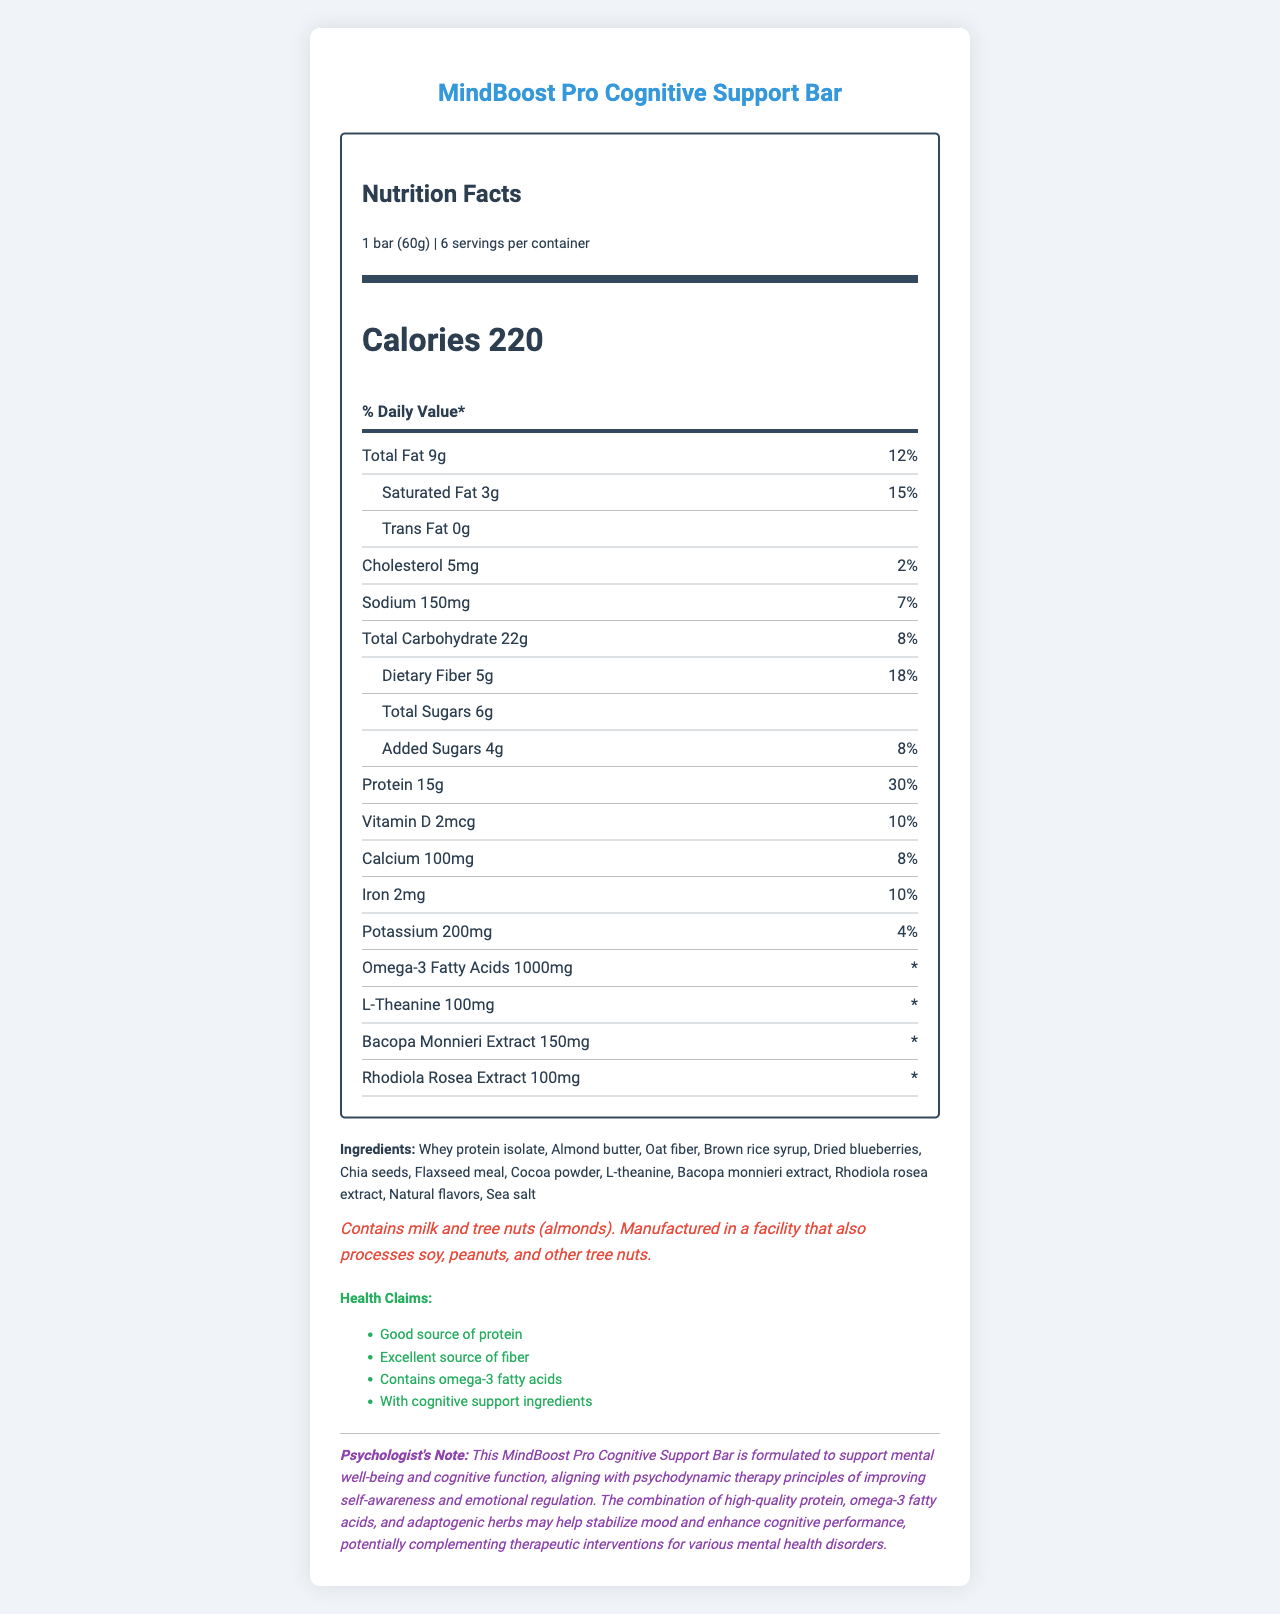what is the serving size of the MindBoost Pro Cognitive Support Bar? The serving size is listed in the "serving-info" section of the Nutrition Facts.
Answer: 1 bar (60g) how many servings are in one container? The number of servings per container is listed as 6 in the "serving-info" section of the document.
Answer: 6 servings what is the amount of protein per serving? The amount of protein is listed in the "nutrient" section with other nutrients.
Answer: 15g what ingredients are included in the MindBoost Pro Cognitive Support Bar? The ingredients are detailed in the "ingredients" section of the document.
Answer: Whey protein isolate, Almond butter, Oat fiber, Brown rice syrup, Dried blueberries, Chia seeds, Flaxseed meal, Cocoa powder, L-theanine, Bacopa monnieri extract, Rhodiola rosea extract, Natural flavors, Sea salt what are the allergen warnings for this product? The allergen information is listed in the "allergen-info" section of the document.
Answer: Contains milk and tree nuts (almonds). Manufactured in a facility that also processes soy, peanuts, and other tree nuts. which nutrient has the highest daily value percentage? The daily value percentage for each nutrient is listed next to the amount, and protein has the highest daily value percentage at 30%.
Answer: Protein (30%) how much dietary fiber is in one serving, and what is its daily value percentage? The amount and daily value percentage of dietary fiber are listed in the "total carbohydrate" section with sub-nutrients.
Answer: 5g, 18% which of these ingredients is not listed in the document: A. Whey protein isolate B. Peanut butter C. Cocoa powder? The ingredients are listed in the document, and peanut butter is not one of them.
Answer: B. Peanut butter what is the amount of omega-3 fatty acids per serving? The amount of omega-3 fatty acids is listed in the "nutrient" section.
Answer: 1000mg which health claim is related to mental well-being? A. Good source of protein B. Excellent source of fiber C. Contains omega-3 fatty acids D. With cognitive support ingredients The health claim "With cognitive support ingredients" explicitly relates to mental well-being.
Answer: D. With cognitive support ingredients is there any trans fat in the product? The amount of trans fat is listed as 0g in the "sub-nutrient" section under "total fat."
Answer: No what is the product's calorie count per serving? The calorie count is prominently displayed under the "calories" section of the Nutrition Facts.
Answer: 220 calories what is the psychologist's note about the product related to psychodynamic therapy? The psychologist's note explains the product's formulation and its alignment with psychodynamic therapy principles.
Answer: MindBoost Pro Cognitive Support Bar is formulated to support mental well-being and cognitive function, aligning with psychodynamic therapy principles of improving self-awareness and emotional regulation. summarize the key nutritional features and psychological benefits of the MindBoost Pro Cognitive Support Bar. The document provides detailed nutrition facts, ingredient information, allergen warnings, and health claims, emphasizing the product's cognitive and mood-boosting benefits aligned with psychodynamic therapy.
Answer: The MindBoost Pro Cognitive Support Bar provides a balanced nutritional profile with 15g of protein, 5g of dietary fiber, and essential vitamins and minerals per serving. It also contains specific ingredients like omega-3 fatty acids, L-theanine, Bacopa monnieri, and Rhodiola rosea for cognitive support and mood stability. The psychologist's note highlights the bar's potential to aid mental well-being and cognitive function, aligning with the principles of psychodynamic therapy. how does the product impact cognitive function and mood stability? While the document includes ingredients intended to support cognitive function and mood stability, it does not provide detailed explanations on how each ingredient achieves these effects.
Answer: Not enough information 